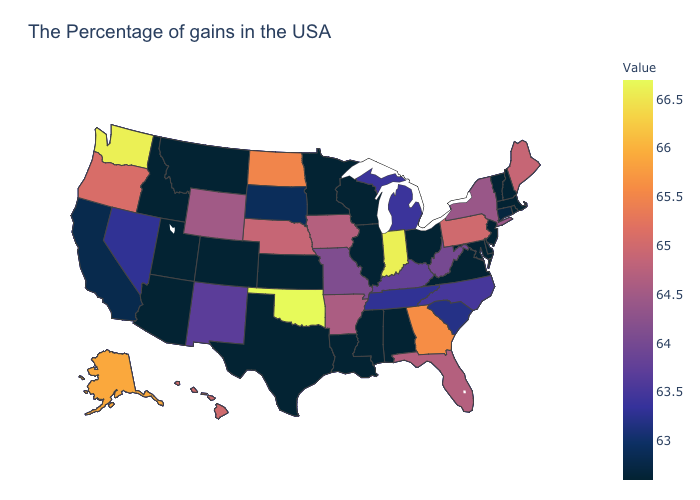Does the map have missing data?
Quick response, please. No. Which states have the highest value in the USA?
Answer briefly. Oklahoma. Does Oklahoma have the highest value in the USA?
Write a very short answer. Yes. Does New Hampshire have the lowest value in the USA?
Answer briefly. Yes. Which states hav the highest value in the West?
Keep it brief. Washington. Does Maryland have the highest value in the USA?
Be succinct. No. 